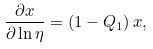Convert formula to latex. <formula><loc_0><loc_0><loc_500><loc_500>\frac { \partial x } { \partial \ln \eta } = \left ( 1 - Q _ { 1 } \right ) x ,</formula> 